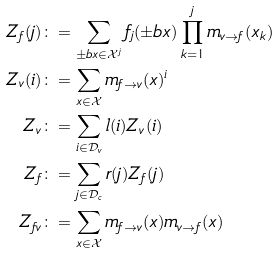<formula> <loc_0><loc_0><loc_500><loc_500>Z _ { f } ( j ) & \colon = \sum _ { \pm b { x } \in \mathcal { X } ^ { j } } f _ { j } ( \pm b { x } ) \prod _ { k = 1 } ^ { j } m _ { v \to f } ( x _ { k } ) \\ Z _ { v } ( i ) & \colon = \sum _ { x \in \mathcal { X } } m _ { f \to v } ( x ) ^ { i } \\ Z _ { v } & \colon = \sum _ { i \in \mathcal { D } _ { v } } l ( i ) Z _ { v } ( i ) \\ Z _ { f } & \colon = \sum _ { j \in \mathcal { D } _ { c } } r ( j ) Z _ { f } ( j ) \\ Z _ { f v } & \colon = \sum _ { x \in \mathcal { X } } m _ { f \to v } ( x ) m _ { v \to f } ( x )</formula> 